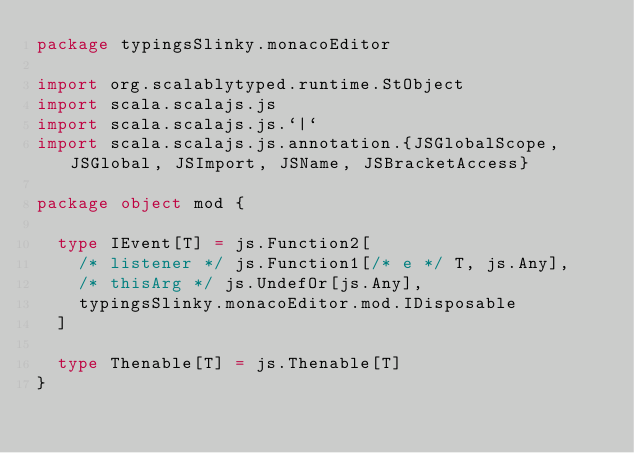<code> <loc_0><loc_0><loc_500><loc_500><_Scala_>package typingsSlinky.monacoEditor

import org.scalablytyped.runtime.StObject
import scala.scalajs.js
import scala.scalajs.js.`|`
import scala.scalajs.js.annotation.{JSGlobalScope, JSGlobal, JSImport, JSName, JSBracketAccess}

package object mod {
  
  type IEvent[T] = js.Function2[
    /* listener */ js.Function1[/* e */ T, js.Any], 
    /* thisArg */ js.UndefOr[js.Any], 
    typingsSlinky.monacoEditor.mod.IDisposable
  ]
  
  type Thenable[T] = js.Thenable[T]
}
</code> 